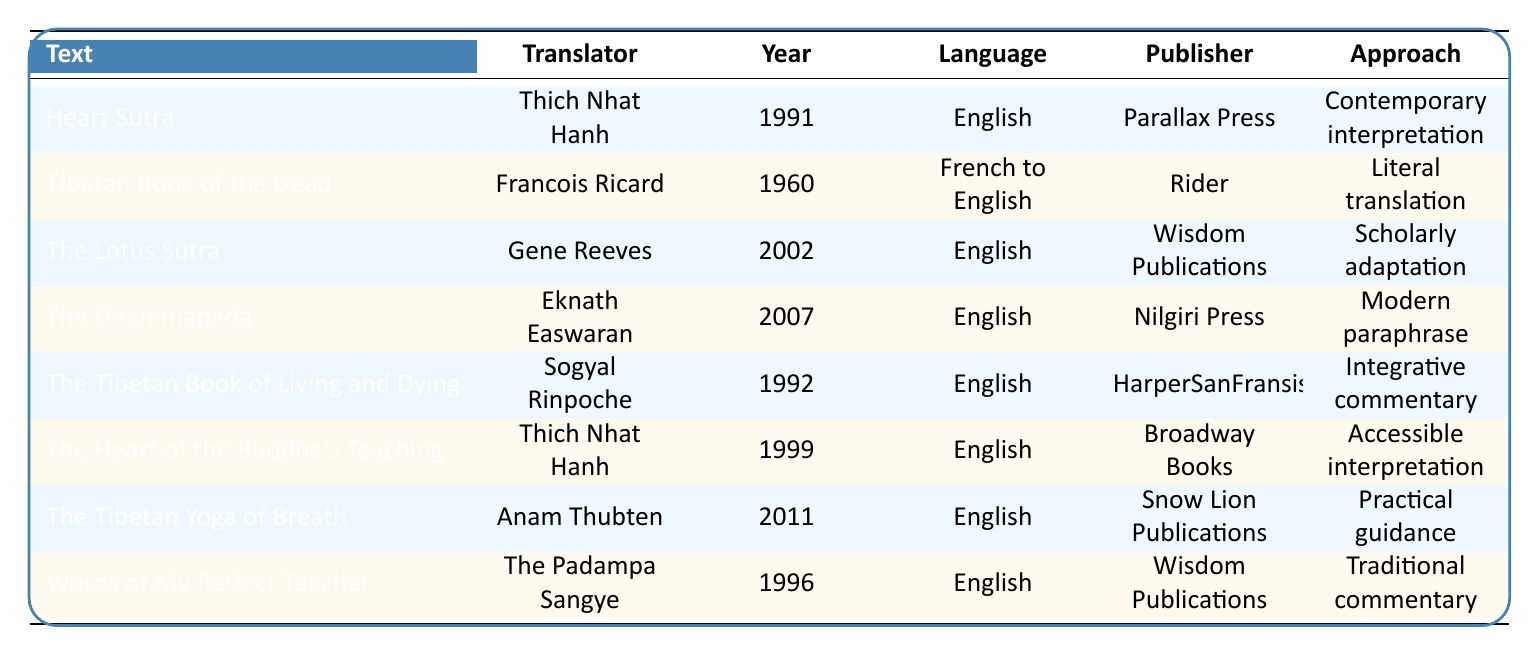What is the publishing year of the Heart Sutra? The Heart Sutra is listed in the first row of the table, which indicates that it was published in 1991.
Answer: 1991 Who translated The Tibetan Book of the Dead? The Tibetan Book of the Dead is found in the second row, and the translator is identified as Francois Ricard.
Answer: Francois Ricard How many texts were translated into English? By examining the Language column, we count the entries that specify "English." There are six instances of English translations in the table.
Answer: 6 Is the translator of The Dhammapada Thich Nhat Hanh? Looking at the row for The Dhammapada, the translator is listed as Eknath Easwaran, not Thich Nhat Hanh, so this statement is false.
Answer: No Which text has the latest year of translation, and who is its translator? The latest year listed in the table is 2011, associated with The Tibetan Yoga of Breath. The translator for this text is Anam Thubten.
Answer: The Tibetan Yoga of Breath, Anam Thubten What approach was used for the translation of The Lotus Sutra? Referring to the row for The Lotus Sutra, the approach taken is labeled as "Scholarly adaptation."
Answer: Scholarly adaptation How many texts were published by Wisdom Publications? Checking the Publisher column, Wisdom Publications appears for two texts: The Lotus Sutra and Words of My Perfect Teacher. Therefore, there are two texts published by them.
Answer: 2 Was there only one translator for texts published in 1992? The table shows two entries for the year 1992: The Tibetan Book of Living and Dying, translated by Sogyal Rinpoche, and no other texts listed for that year; thus, the statement is true.
Answer: Yes Which translation approaches feature contemporary perspectives? The Heart Sutra and The Tibetan Book of Living and Dying are the two texts that employ contemporary perspectives in their approaches, namely "Contemporary interpretation" and "Integrative commentary," respectively.
Answer: Heart Sutra, The Tibetan Book of Living and Dying 